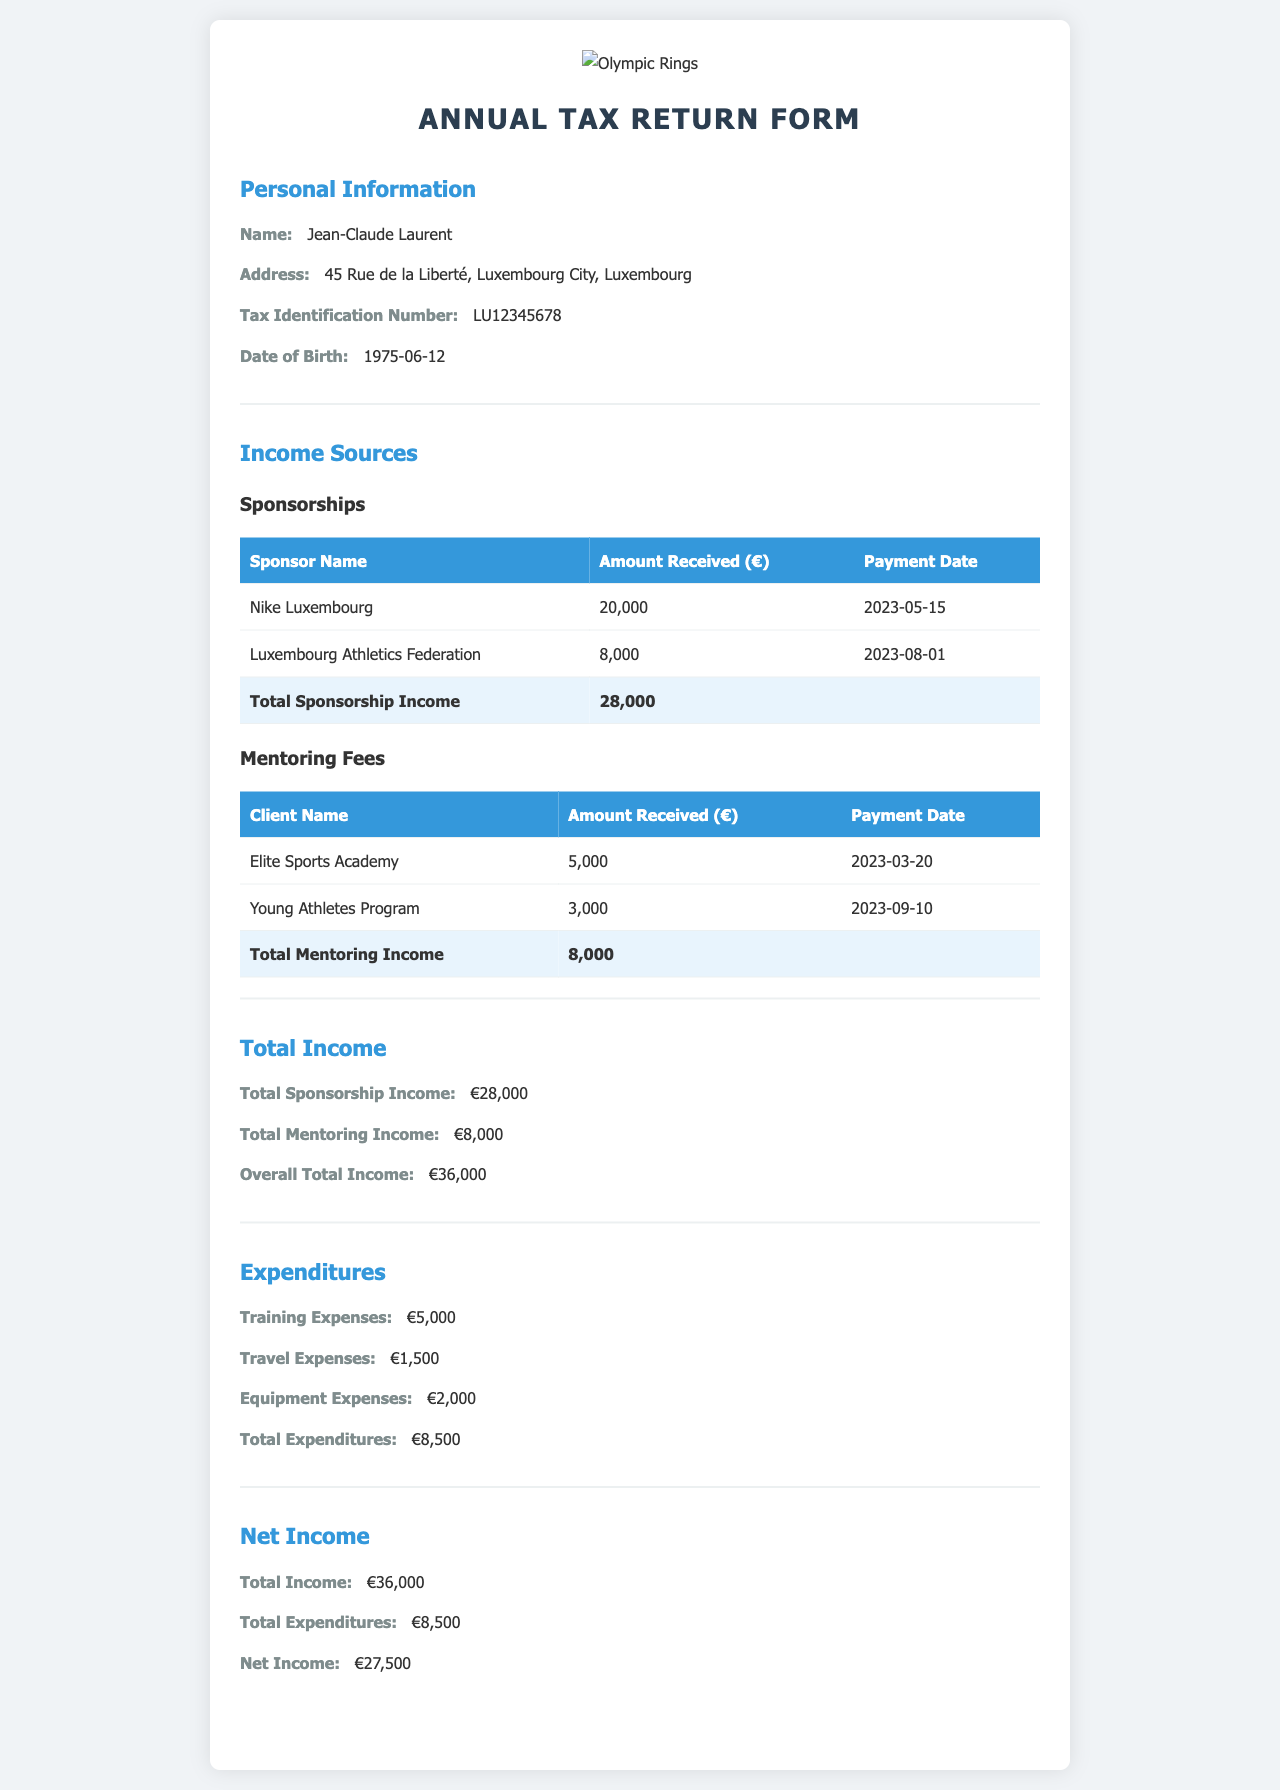What is the name of the individual filing the tax return? The individual's name is listed in the personal information section of the document.
Answer: Jean-Claude Laurent What is the address of Jean-Claude Laurent? The address is provided in the personal information section, detailing the location in Luxembourg City.
Answer: 45 Rue de la Liberté, Luxembourg City, Luxembourg How much income was received from Nike Luxembourg? The amount received from Nike Luxembourg is specified in the sponsorships table under income sources.
Answer: 20,000 What is the total amount of mentoring income? The total mentoring income is indicated in the mentoring fees section summing all received amounts.
Answer: 8,000 What is the overall total income reported? The total income combines all sources of income as shown in the total income section.
Answer: 36,000 What were the total expenditures for the year? The total expenditures are summarized in the expenditures section, combining various costs incurred.
Answer: 8,500 How much net income does Jean-Claude Laurent declare? The net income is provided in the net income section, calculated from total income minus total expenditures.
Answer: 27,500 Which organization provided a payment on 2023-08-01? This date corresponds to an entry in the sponsorships table specifying the organization name.
Answer: Luxembourg Athletics Federation What was the payment date for the amount of 5,000? This amount received is detailed in the mentoring fees section with a specific payment date attached to it.
Answer: 2023-03-20 